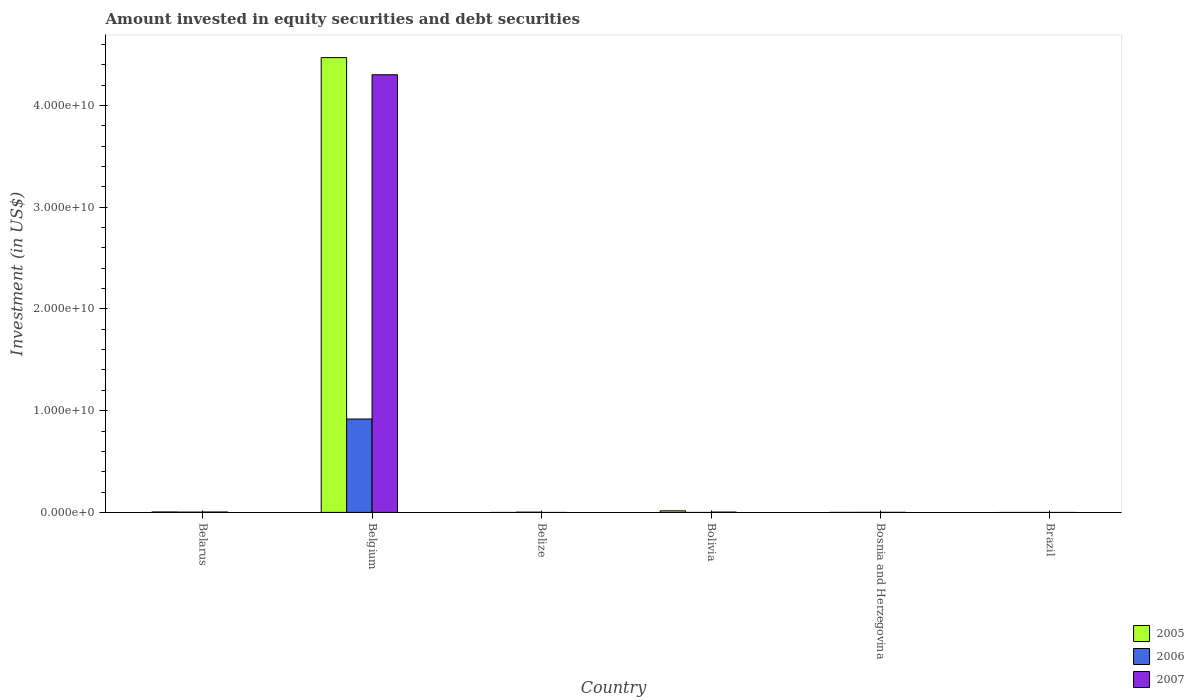Are the number of bars per tick equal to the number of legend labels?
Your answer should be very brief. No. Are the number of bars on each tick of the X-axis equal?
Keep it short and to the point. No. What is the label of the 5th group of bars from the left?
Provide a succinct answer. Bosnia and Herzegovina. What is the amount invested in equity securities and debt securities in 2007 in Bolivia?
Provide a succinct answer. 2.99e+07. Across all countries, what is the maximum amount invested in equity securities and debt securities in 2007?
Offer a terse response. 4.30e+1. What is the total amount invested in equity securities and debt securities in 2007 in the graph?
Provide a succinct answer. 4.31e+1. What is the difference between the amount invested in equity securities and debt securities in 2006 in Belgium and that in Belize?
Give a very brief answer. 9.16e+09. What is the difference between the amount invested in equity securities and debt securities in 2006 in Belize and the amount invested in equity securities and debt securities in 2005 in Bosnia and Herzegovina?
Your answer should be very brief. 2.16e+07. What is the average amount invested in equity securities and debt securities in 2006 per country?
Keep it short and to the point. 1.54e+09. What is the difference between the amount invested in equity securities and debt securities of/in 2007 and amount invested in equity securities and debt securities of/in 2006 in Bosnia and Herzegovina?
Provide a short and direct response. 2.31e+06. What is the ratio of the amount invested in equity securities and debt securities in 2007 in Bolivia to that in Bosnia and Herzegovina?
Keep it short and to the point. 11.07. What is the difference between the highest and the second highest amount invested in equity securities and debt securities in 2007?
Ensure brevity in your answer.  -4.30e+1. What is the difference between the highest and the lowest amount invested in equity securities and debt securities in 2006?
Your answer should be compact. 9.18e+09. In how many countries, is the amount invested in equity securities and debt securities in 2006 greater than the average amount invested in equity securities and debt securities in 2006 taken over all countries?
Your answer should be very brief. 1. Is it the case that in every country, the sum of the amount invested in equity securities and debt securities in 2006 and amount invested in equity securities and debt securities in 2005 is greater than the amount invested in equity securities and debt securities in 2007?
Your answer should be very brief. No. How many countries are there in the graph?
Offer a very short reply. 6. What is the difference between two consecutive major ticks on the Y-axis?
Offer a terse response. 1.00e+1. How many legend labels are there?
Provide a short and direct response. 3. What is the title of the graph?
Provide a succinct answer. Amount invested in equity securities and debt securities. What is the label or title of the Y-axis?
Provide a short and direct response. Investment (in US$). What is the Investment (in US$) of 2005 in Belarus?
Provide a succinct answer. 4.15e+07. What is the Investment (in US$) of 2006 in Belarus?
Your answer should be compact. 2.64e+07. What is the Investment (in US$) of 2007 in Belarus?
Your answer should be very brief. 3.88e+07. What is the Investment (in US$) in 2005 in Belgium?
Your answer should be compact. 4.47e+1. What is the Investment (in US$) in 2006 in Belgium?
Ensure brevity in your answer.  9.18e+09. What is the Investment (in US$) in 2007 in Belgium?
Keep it short and to the point. 4.30e+1. What is the Investment (in US$) of 2005 in Belize?
Ensure brevity in your answer.  0. What is the Investment (in US$) of 2006 in Belize?
Provide a short and direct response. 2.16e+07. What is the Investment (in US$) in 2005 in Bolivia?
Make the answer very short. 1.53e+08. What is the Investment (in US$) of 2006 in Bolivia?
Give a very brief answer. 0. What is the Investment (in US$) of 2007 in Bolivia?
Make the answer very short. 2.99e+07. What is the Investment (in US$) of 2006 in Bosnia and Herzegovina?
Ensure brevity in your answer.  3.88e+05. What is the Investment (in US$) of 2007 in Bosnia and Herzegovina?
Make the answer very short. 2.70e+06. What is the Investment (in US$) of 2007 in Brazil?
Provide a short and direct response. 0. Across all countries, what is the maximum Investment (in US$) of 2005?
Your answer should be compact. 4.47e+1. Across all countries, what is the maximum Investment (in US$) of 2006?
Your answer should be compact. 9.18e+09. Across all countries, what is the maximum Investment (in US$) of 2007?
Keep it short and to the point. 4.30e+1. Across all countries, what is the minimum Investment (in US$) in 2005?
Provide a succinct answer. 0. What is the total Investment (in US$) in 2005 in the graph?
Ensure brevity in your answer.  4.49e+1. What is the total Investment (in US$) in 2006 in the graph?
Provide a succinct answer. 9.23e+09. What is the total Investment (in US$) of 2007 in the graph?
Offer a terse response. 4.31e+1. What is the difference between the Investment (in US$) of 2005 in Belarus and that in Belgium?
Your answer should be compact. -4.47e+1. What is the difference between the Investment (in US$) in 2006 in Belarus and that in Belgium?
Make the answer very short. -9.15e+09. What is the difference between the Investment (in US$) in 2007 in Belarus and that in Belgium?
Your answer should be very brief. -4.30e+1. What is the difference between the Investment (in US$) in 2006 in Belarus and that in Belize?
Provide a short and direct response. 4.79e+06. What is the difference between the Investment (in US$) in 2005 in Belarus and that in Bolivia?
Give a very brief answer. -1.12e+08. What is the difference between the Investment (in US$) of 2007 in Belarus and that in Bolivia?
Your answer should be compact. 8.90e+06. What is the difference between the Investment (in US$) of 2006 in Belarus and that in Bosnia and Herzegovina?
Give a very brief answer. 2.60e+07. What is the difference between the Investment (in US$) in 2007 in Belarus and that in Bosnia and Herzegovina?
Make the answer very short. 3.61e+07. What is the difference between the Investment (in US$) in 2006 in Belgium and that in Belize?
Ensure brevity in your answer.  9.16e+09. What is the difference between the Investment (in US$) in 2005 in Belgium and that in Bolivia?
Give a very brief answer. 4.46e+1. What is the difference between the Investment (in US$) of 2007 in Belgium and that in Bolivia?
Provide a succinct answer. 4.30e+1. What is the difference between the Investment (in US$) in 2006 in Belgium and that in Bosnia and Herzegovina?
Your answer should be compact. 9.18e+09. What is the difference between the Investment (in US$) of 2007 in Belgium and that in Bosnia and Herzegovina?
Your response must be concise. 4.30e+1. What is the difference between the Investment (in US$) in 2006 in Belize and that in Bosnia and Herzegovina?
Provide a short and direct response. 2.12e+07. What is the difference between the Investment (in US$) in 2007 in Bolivia and that in Bosnia and Herzegovina?
Keep it short and to the point. 2.72e+07. What is the difference between the Investment (in US$) of 2005 in Belarus and the Investment (in US$) of 2006 in Belgium?
Give a very brief answer. -9.14e+09. What is the difference between the Investment (in US$) in 2005 in Belarus and the Investment (in US$) in 2007 in Belgium?
Your answer should be compact. -4.30e+1. What is the difference between the Investment (in US$) of 2006 in Belarus and the Investment (in US$) of 2007 in Belgium?
Your answer should be very brief. -4.30e+1. What is the difference between the Investment (in US$) in 2005 in Belarus and the Investment (in US$) in 2006 in Belize?
Offer a very short reply. 1.99e+07. What is the difference between the Investment (in US$) of 2005 in Belarus and the Investment (in US$) of 2007 in Bolivia?
Offer a very short reply. 1.16e+07. What is the difference between the Investment (in US$) in 2006 in Belarus and the Investment (in US$) in 2007 in Bolivia?
Make the answer very short. -3.50e+06. What is the difference between the Investment (in US$) in 2005 in Belarus and the Investment (in US$) in 2006 in Bosnia and Herzegovina?
Provide a succinct answer. 4.11e+07. What is the difference between the Investment (in US$) in 2005 in Belarus and the Investment (in US$) in 2007 in Bosnia and Herzegovina?
Provide a short and direct response. 3.88e+07. What is the difference between the Investment (in US$) in 2006 in Belarus and the Investment (in US$) in 2007 in Bosnia and Herzegovina?
Provide a short and direct response. 2.37e+07. What is the difference between the Investment (in US$) in 2005 in Belgium and the Investment (in US$) in 2006 in Belize?
Ensure brevity in your answer.  4.47e+1. What is the difference between the Investment (in US$) of 2005 in Belgium and the Investment (in US$) of 2007 in Bolivia?
Offer a terse response. 4.47e+1. What is the difference between the Investment (in US$) in 2006 in Belgium and the Investment (in US$) in 2007 in Bolivia?
Keep it short and to the point. 9.15e+09. What is the difference between the Investment (in US$) of 2005 in Belgium and the Investment (in US$) of 2006 in Bosnia and Herzegovina?
Make the answer very short. 4.47e+1. What is the difference between the Investment (in US$) in 2005 in Belgium and the Investment (in US$) in 2007 in Bosnia and Herzegovina?
Your response must be concise. 4.47e+1. What is the difference between the Investment (in US$) in 2006 in Belgium and the Investment (in US$) in 2007 in Bosnia and Herzegovina?
Offer a very short reply. 9.18e+09. What is the difference between the Investment (in US$) of 2006 in Belize and the Investment (in US$) of 2007 in Bolivia?
Ensure brevity in your answer.  -8.30e+06. What is the difference between the Investment (in US$) of 2006 in Belize and the Investment (in US$) of 2007 in Bosnia and Herzegovina?
Ensure brevity in your answer.  1.89e+07. What is the difference between the Investment (in US$) of 2005 in Bolivia and the Investment (in US$) of 2006 in Bosnia and Herzegovina?
Provide a short and direct response. 1.53e+08. What is the difference between the Investment (in US$) in 2005 in Bolivia and the Investment (in US$) in 2007 in Bosnia and Herzegovina?
Make the answer very short. 1.51e+08. What is the average Investment (in US$) in 2005 per country?
Make the answer very short. 7.48e+09. What is the average Investment (in US$) of 2006 per country?
Give a very brief answer. 1.54e+09. What is the average Investment (in US$) of 2007 per country?
Ensure brevity in your answer.  7.18e+09. What is the difference between the Investment (in US$) in 2005 and Investment (in US$) in 2006 in Belarus?
Provide a short and direct response. 1.51e+07. What is the difference between the Investment (in US$) in 2005 and Investment (in US$) in 2007 in Belarus?
Offer a terse response. 2.70e+06. What is the difference between the Investment (in US$) in 2006 and Investment (in US$) in 2007 in Belarus?
Offer a terse response. -1.24e+07. What is the difference between the Investment (in US$) in 2005 and Investment (in US$) in 2006 in Belgium?
Provide a succinct answer. 3.55e+1. What is the difference between the Investment (in US$) in 2005 and Investment (in US$) in 2007 in Belgium?
Give a very brief answer. 1.68e+09. What is the difference between the Investment (in US$) of 2006 and Investment (in US$) of 2007 in Belgium?
Provide a short and direct response. -3.38e+1. What is the difference between the Investment (in US$) in 2005 and Investment (in US$) in 2007 in Bolivia?
Your response must be concise. 1.24e+08. What is the difference between the Investment (in US$) of 2006 and Investment (in US$) of 2007 in Bosnia and Herzegovina?
Your answer should be compact. -2.31e+06. What is the ratio of the Investment (in US$) in 2005 in Belarus to that in Belgium?
Your answer should be compact. 0. What is the ratio of the Investment (in US$) of 2006 in Belarus to that in Belgium?
Provide a succinct answer. 0. What is the ratio of the Investment (in US$) in 2007 in Belarus to that in Belgium?
Provide a short and direct response. 0. What is the ratio of the Investment (in US$) of 2006 in Belarus to that in Belize?
Offer a terse response. 1.22. What is the ratio of the Investment (in US$) in 2005 in Belarus to that in Bolivia?
Offer a very short reply. 0.27. What is the ratio of the Investment (in US$) in 2007 in Belarus to that in Bolivia?
Provide a succinct answer. 1.3. What is the ratio of the Investment (in US$) in 2006 in Belarus to that in Bosnia and Herzegovina?
Make the answer very short. 67.97. What is the ratio of the Investment (in US$) in 2007 in Belarus to that in Bosnia and Herzegovina?
Your response must be concise. 14.36. What is the ratio of the Investment (in US$) of 2006 in Belgium to that in Belize?
Keep it short and to the point. 424.9. What is the ratio of the Investment (in US$) in 2005 in Belgium to that in Bolivia?
Your answer should be very brief. 291.38. What is the ratio of the Investment (in US$) in 2007 in Belgium to that in Bolivia?
Your answer should be compact. 1438.73. What is the ratio of the Investment (in US$) in 2006 in Belgium to that in Bosnia and Herzegovina?
Ensure brevity in your answer.  2.36e+04. What is the ratio of the Investment (in US$) in 2007 in Belgium to that in Bosnia and Herzegovina?
Your answer should be very brief. 1.59e+04. What is the ratio of the Investment (in US$) in 2006 in Belize to that in Bosnia and Herzegovina?
Make the answer very short. 55.62. What is the ratio of the Investment (in US$) in 2007 in Bolivia to that in Bosnia and Herzegovina?
Offer a very short reply. 11.07. What is the difference between the highest and the second highest Investment (in US$) of 2005?
Give a very brief answer. 4.46e+1. What is the difference between the highest and the second highest Investment (in US$) in 2006?
Offer a very short reply. 9.15e+09. What is the difference between the highest and the second highest Investment (in US$) in 2007?
Keep it short and to the point. 4.30e+1. What is the difference between the highest and the lowest Investment (in US$) in 2005?
Offer a terse response. 4.47e+1. What is the difference between the highest and the lowest Investment (in US$) of 2006?
Make the answer very short. 9.18e+09. What is the difference between the highest and the lowest Investment (in US$) of 2007?
Give a very brief answer. 4.30e+1. 